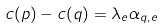<formula> <loc_0><loc_0><loc_500><loc_500>c ( p ) - c ( q ) = \lambda _ { e } \alpha _ { q , e }</formula> 